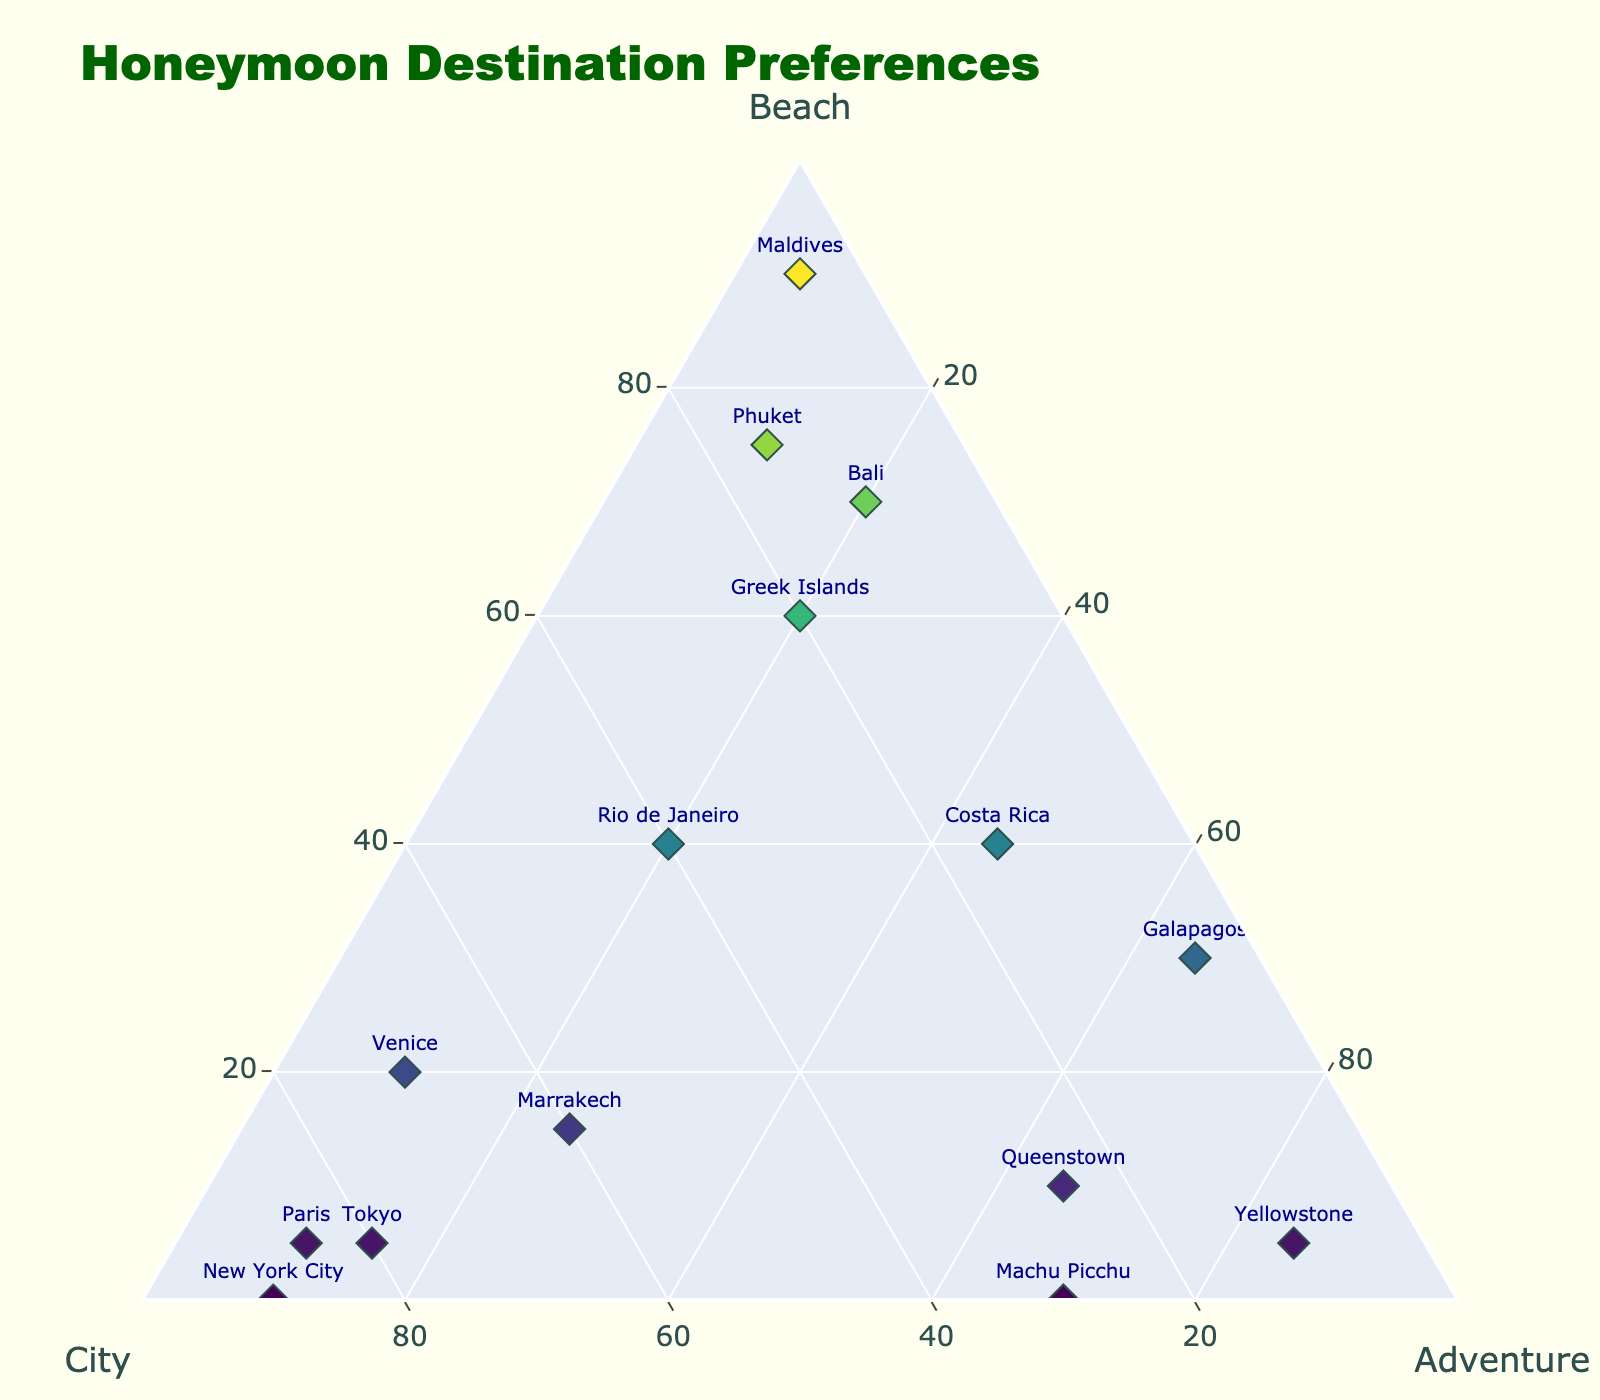What's the title of the figure? The title of the figure is usually displayed at the top. It is defined clearly and reads "Honeymoon Destination Preferences".
Answer: Honeymoon Destination Preferences How many destinations have a preference for beach higher than 50? By examining the plot, we can count the number of destinations where the 'Beach' axis value is greater than 50. These are Bali, Maldives, Greek Islands, and Phuket.
Answer: 4 Which destination has the highest city preference? We need to look for the data point with the maximum value along the 'City' axis. New York City and Paris both have a city preference of 90.
Answer: New York City, and Paris What's the difference in beach preference between Bali and Maldives? Bali's beach preference is 70, and Maldives is 90. The difference is calculated as 90 - 70.
Answer: 20 What is the average adventure preference across all destinations? To find the average, sum the adventure preferences of all destinations and divide by the number of destinations. The sum is 630, and there are 15 destinations, so average = 630 / 15.
Answer: 42 Which destination has the closest balance between beach, city, and adventure preferences? By examining the plot, we look for the data point closest to the center of the triangle. Costa Rica has values 40, 15, 45 that are more balanced than others.
Answer: Costa Rica Which destination has the second-highest city preference? Sorting the city preferences, the highest is New York City with 90, followed by Paris with 85, then Tokyo with 80. Thus, the second highest directly after New York City is Paris.
Answer: Paris What is the sum of beach preferences for destinations with an adventure preference higher than 40? The destinations are Costa Rica, Queenstown, Machu Picchu, Galapagos, Yellowstone. Their beach preferences are 40, 10,  0, 30, 5, respectively. Sum = 40 + 10 + 0 + 30 + 5.
Answer: 85 Which destination has the highest adventure preference? By examining the adventure axis, we identify that Yellowstone has the highest adventure preference value of 85.
Answer: Yellowstone 